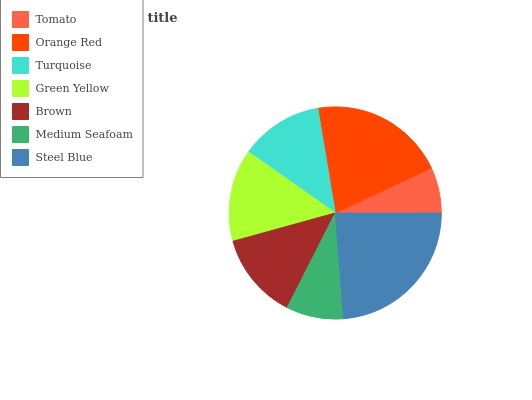Is Tomato the minimum?
Answer yes or no. Yes. Is Steel Blue the maximum?
Answer yes or no. Yes. Is Orange Red the minimum?
Answer yes or no. No. Is Orange Red the maximum?
Answer yes or no. No. Is Orange Red greater than Tomato?
Answer yes or no. Yes. Is Tomato less than Orange Red?
Answer yes or no. Yes. Is Tomato greater than Orange Red?
Answer yes or no. No. Is Orange Red less than Tomato?
Answer yes or no. No. Is Brown the high median?
Answer yes or no. Yes. Is Brown the low median?
Answer yes or no. Yes. Is Tomato the high median?
Answer yes or no. No. Is Tomato the low median?
Answer yes or no. No. 